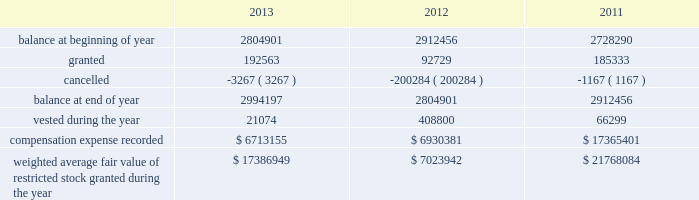During the years ended december 31 , 2013 , 2012 , and 2011 , we recognized approximately $ 6.5 million , $ 5.1 million and $ 4.7 million of compensation expense , respectively , for these options .
As of december 31 , 2013 , there was approximately $ 20.3 million of total unrecognized compensation cost related to unvested stock options , which is expected to be recognized over a weighted average period of three years .
Stock-based compensation effective january 1 , 1999 , we implemented a deferred compensation plan , or the deferred plan , covering certain of our employees , including our executives .
The shares issued under the deferred plan were granted to certain employees , including our executives and vesting will occur annually upon the completion of a service period or our meeting established financial performance criteria .
Annual vesting occurs at rates ranging from 15% ( 15 % ) to 35% ( 35 % ) once performance criteria are reached .
A summary of our restricted stock as of december 31 , 2013 , 2012 and 2011 and charges during the years then ended are presented below: .
Weighted average fair value of restricted stock granted during the year $ 17386949 $ 7023942 $ 21768084 the fair value of restricted stock that vested during the years ended december 31 , 2013 , 2012 and 2011 was $ 1.6 million , $ 22.4 million and $ 4.3 million , respectively .
As of december 31 , 2013 , there was $ 17.8 million of total unrecognized compensation cost related to unvested restricted stock , which is expected to be recognized over a weighted average period of approximately 2.7 years .
For the years ended december 31 , 2013 , 2012 and 2011 , approximately $ 4.5 million , $ 4.1 million and $ 3.4 million , respectively , was capitalized to assets associated with compensation expense related to our long-term compensation plans , restricted stock and stock options .
We granted ltip units , which include bonus , time-based and performance based awards , with a fair value of $ 27.1 million , zero and $ 8.5 million as of 2013 , 2012 and 2011 , respectively .
The grant date fair value of the ltip unit awards was calculated in accordance with asc 718 .
A third party consultant determined the fair value of the ltip units to have a discount from sl green's common stock price .
The discount was calculated by considering the inherent uncertainty that the ltip units will reach parity with other common partnership units and the illiquidity due to transfer restrictions .
As of december 31 , 2013 , there was $ 5.0 million of total unrecognized compensation expense related to the time-based and performance based awards , which is expected to be recognized over a weighted average period of approximately 1.5 years .
During the years ended december 31 , 2013 , 2012 and 2011 , we recorded compensation expense related to bonus , time-based and performance based awards of approximately $ 27.3 million , $ 12.6 million and $ 8.5 million , respectively .
2010 notional unit long-term compensation plan in december 2009 , the compensation committee of the company's board of directors approved the general terms of the sl green realty corp .
2010 notional unit long-term compensation program , or the 2010 long-term compensation plan .
The 2010 long-term compensation plan is a long-term incentive compensation plan pursuant to which award recipients could earn , in the aggregate , from approximately $ 15.0 million up to approximately $ 75.0 million of ltip units in the operating partnership based on our stock price appreciation over three years beginning on december 1 , 2009 ; provided that , if maximum performance had been achieved , approximately $ 25.0 million of awards could be earned at any time after the beginning of the second year and an additional approximately $ 25.0 million of awards could be earned at any time after the beginning of the third year .
In order to achieve maximum performance under the 2010 long-term compensation plan , our aggregate stock price appreciation during the performance period had to equal or exceed 50% ( 50 % ) .
The compensation committee determined that maximum performance had been achieved at or shortly after the beginning of each of the second and third years of the performance period and for the full performance period and , accordingly , 366815 ltip units , 385583 ltip units and 327416 ltip units were earned under the 2010 long-term compensation plan in december 2010 , 2011 and 2012 , respectively .
Substantially in accordance with the original terms of the program , 50% ( 50 % ) of these ltip units vested on december 17 , 2012 ( accelerated from the original january 1 , 2013 vesting date ) , 25% ( 25 % ) of these ltip units vested on december 11 , 2013 ( accelerated from the original january 1 , 2014 vesting date ) and the remainder is scheduled to vest on january 1 , 2015 based on .
What was the average recorded compensation expense related to bonus , time-based and performance based awards from 2011 to 2013? 
Computations: (((27.3 + 12.6) + 8.5) / 3)
Answer: 16.13333. 